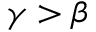Convert formula to latex. <formula><loc_0><loc_0><loc_500><loc_500>\gamma > \beta</formula> 